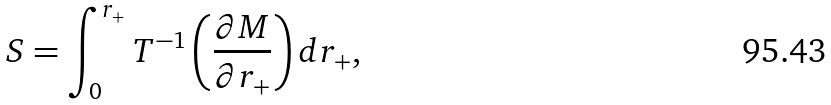<formula> <loc_0><loc_0><loc_500><loc_500>S = \int _ { 0 } ^ { r _ { + } } T ^ { - 1 } \left ( \frac { \partial M } { \partial r _ { + } } \right ) d r _ { + } ,</formula> 